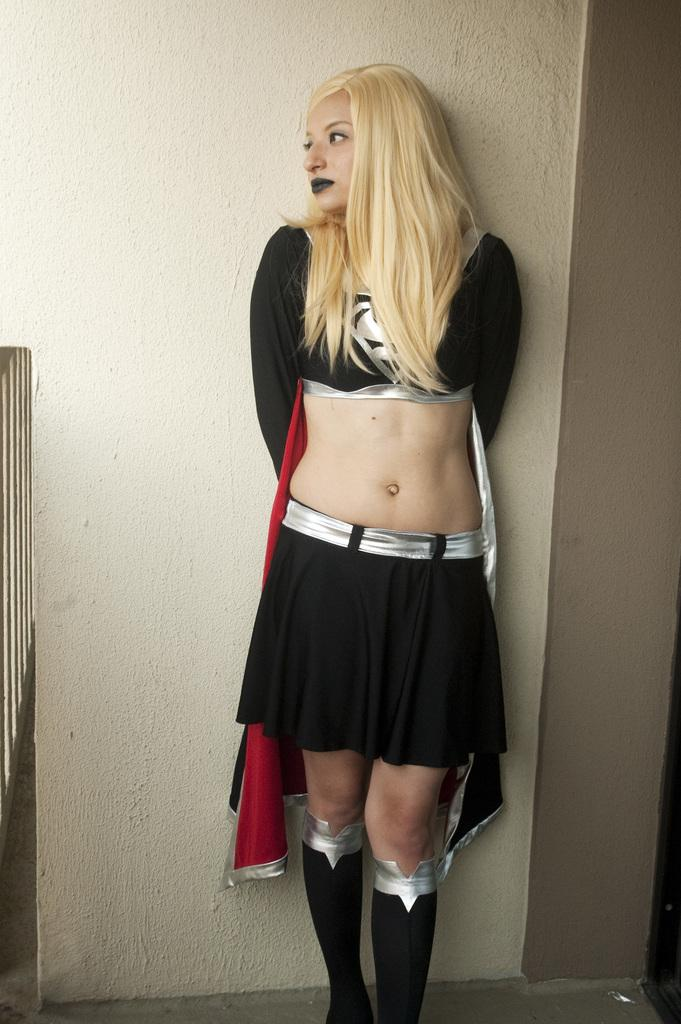What is the main subject of the image? There is a woman standing in the image. What is the woman wearing? The woman is wearing clothes and boots. What type of surface is visible beneath the woman? There is a floor in the image. What is the background of the image composed of? There is a wall in the image. What type of force is being applied to the wall in the image? There is no force being applied to the wall in the image; it is simply a background element. 